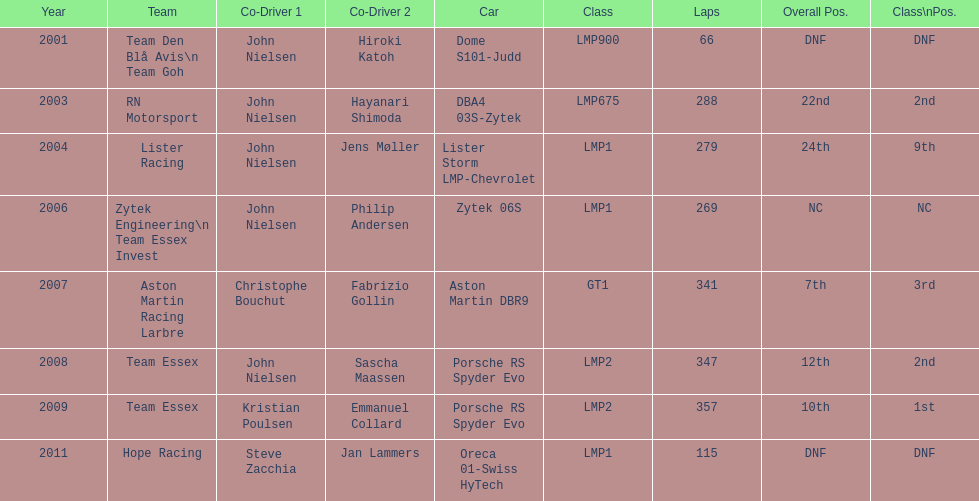How many times was the porsche rs spyder used in competition? 2. 